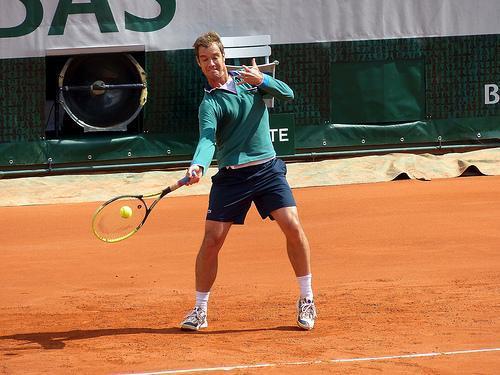How many balls are in the photo?
Give a very brief answer. 1. 